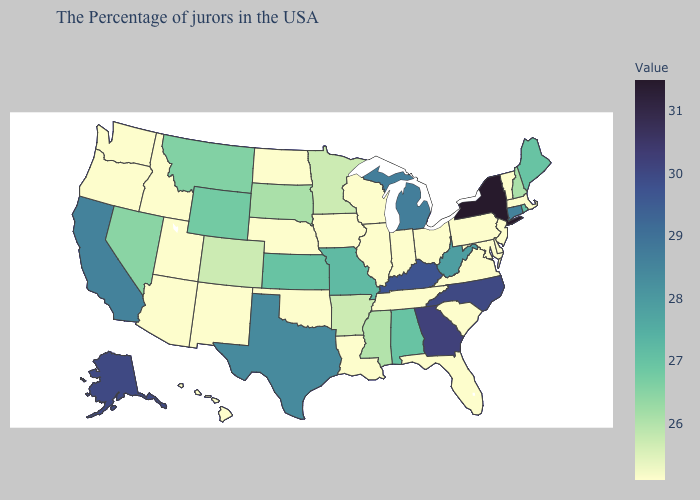Does Wyoming have the lowest value in the West?
Answer briefly. No. Does New York have a lower value than Illinois?
Quick response, please. No. Does California have the lowest value in the West?
Be succinct. No. Which states hav the highest value in the Northeast?
Short answer required. New York. Which states have the lowest value in the South?
Write a very short answer. Delaware, Maryland, Virginia, South Carolina, Florida, Tennessee, Louisiana, Oklahoma. 